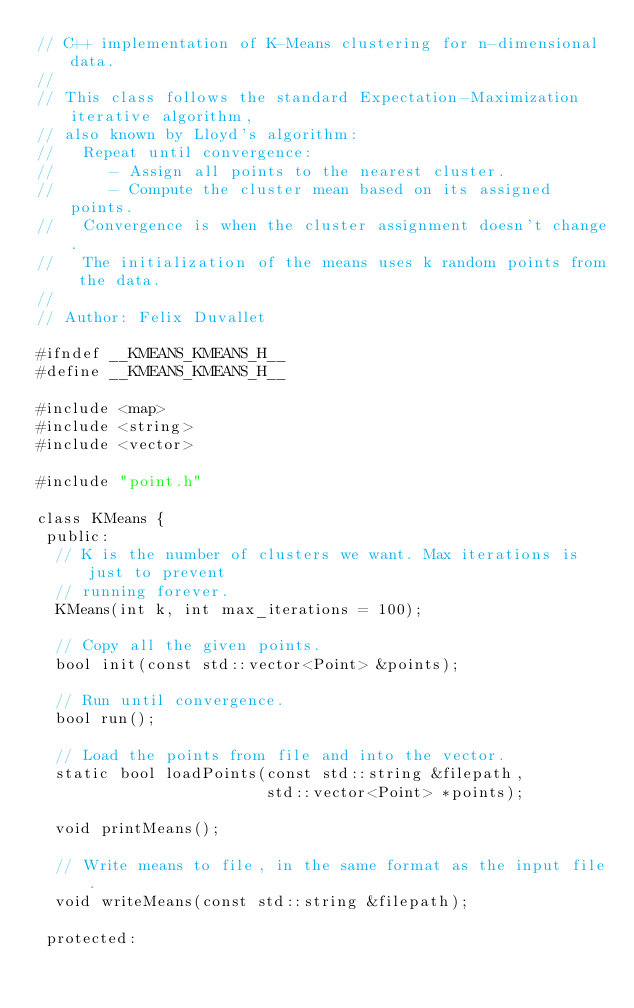Convert code to text. <code><loc_0><loc_0><loc_500><loc_500><_C_>// C++ implementation of K-Means clustering for n-dimensional data.
//
// This class follows the standard Expectation-Maximization iterative algorithm,
// also known by Lloyd's algorithm:
//   Repeat until convergence:
//      - Assign all points to the nearest cluster.
//      - Compute the cluster mean based on its assigned points.
//   Convergence is when the cluster assignment doesn't change.
//   The initialization of the means uses k random points from the data.
//
// Author: Felix Duvallet

#ifndef __KMEANS_KMEANS_H__
#define __KMEANS_KMEANS_H__

#include <map>
#include <string>
#include <vector>

#include "point.h"

class KMeans {
 public:
  // K is the number of clusters we want. Max iterations is just to prevent
  // running forever.
  KMeans(int k, int max_iterations = 100);

  // Copy all the given points.
  bool init(const std::vector<Point> &points);

  // Run until convergence.
  bool run();

  // Load the points from file and into the vector.
  static bool loadPoints(const std::string &filepath,
                         std::vector<Point> *points);

  void printMeans();

  // Write means to file, in the same format as the input file.
  void writeMeans(const std::string &filepath);

 protected:</code> 